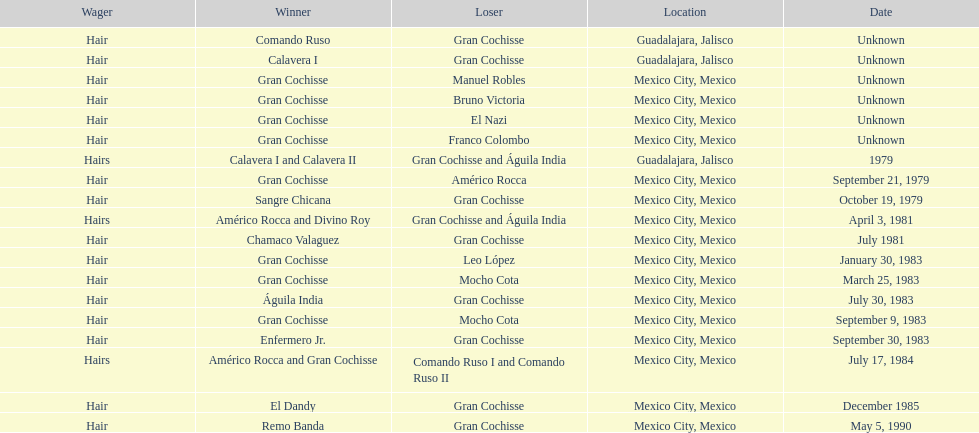What was the count of defeats gran cochisse experienced against el dandy? 1. 